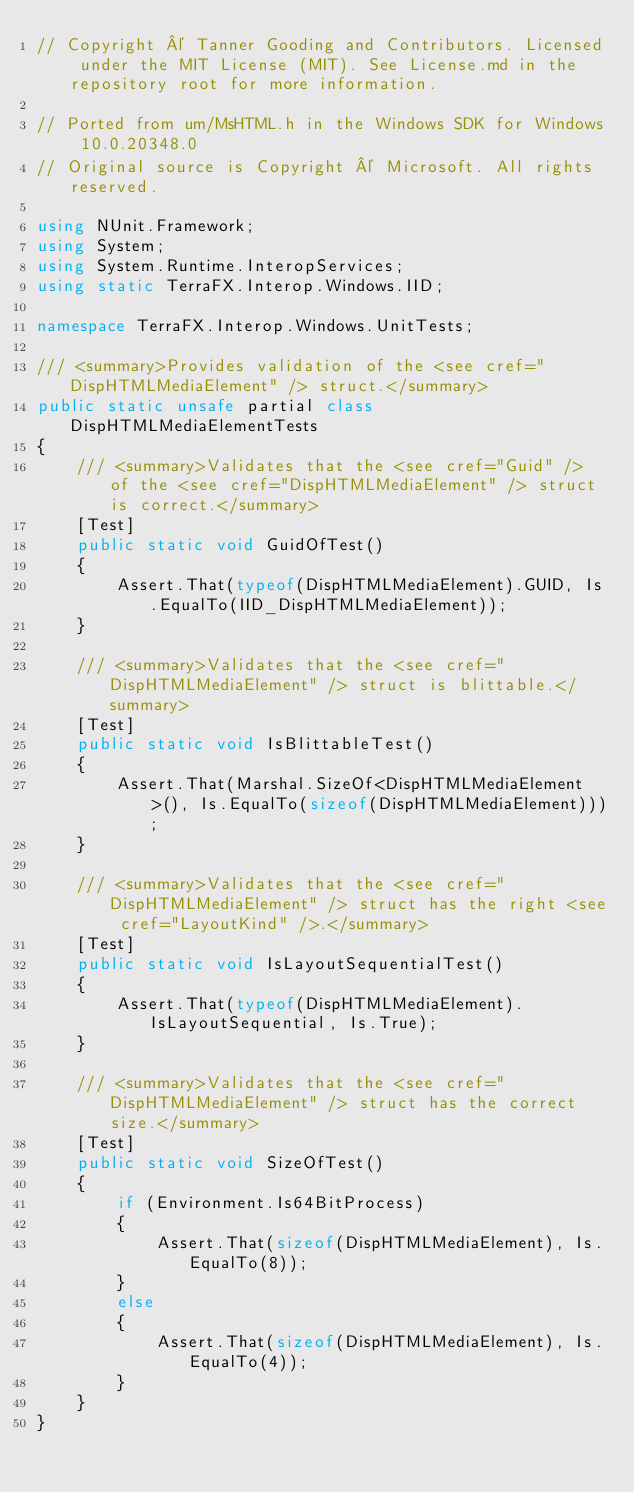<code> <loc_0><loc_0><loc_500><loc_500><_C#_>// Copyright © Tanner Gooding and Contributors. Licensed under the MIT License (MIT). See License.md in the repository root for more information.

// Ported from um/MsHTML.h in the Windows SDK for Windows 10.0.20348.0
// Original source is Copyright © Microsoft. All rights reserved.

using NUnit.Framework;
using System;
using System.Runtime.InteropServices;
using static TerraFX.Interop.Windows.IID;

namespace TerraFX.Interop.Windows.UnitTests;

/// <summary>Provides validation of the <see cref="DispHTMLMediaElement" /> struct.</summary>
public static unsafe partial class DispHTMLMediaElementTests
{
    /// <summary>Validates that the <see cref="Guid" /> of the <see cref="DispHTMLMediaElement" /> struct is correct.</summary>
    [Test]
    public static void GuidOfTest()
    {
        Assert.That(typeof(DispHTMLMediaElement).GUID, Is.EqualTo(IID_DispHTMLMediaElement));
    }

    /// <summary>Validates that the <see cref="DispHTMLMediaElement" /> struct is blittable.</summary>
    [Test]
    public static void IsBlittableTest()
    {
        Assert.That(Marshal.SizeOf<DispHTMLMediaElement>(), Is.EqualTo(sizeof(DispHTMLMediaElement)));
    }

    /// <summary>Validates that the <see cref="DispHTMLMediaElement" /> struct has the right <see cref="LayoutKind" />.</summary>
    [Test]
    public static void IsLayoutSequentialTest()
    {
        Assert.That(typeof(DispHTMLMediaElement).IsLayoutSequential, Is.True);
    }

    /// <summary>Validates that the <see cref="DispHTMLMediaElement" /> struct has the correct size.</summary>
    [Test]
    public static void SizeOfTest()
    {
        if (Environment.Is64BitProcess)
        {
            Assert.That(sizeof(DispHTMLMediaElement), Is.EqualTo(8));
        }
        else
        {
            Assert.That(sizeof(DispHTMLMediaElement), Is.EqualTo(4));
        }
    }
}
</code> 